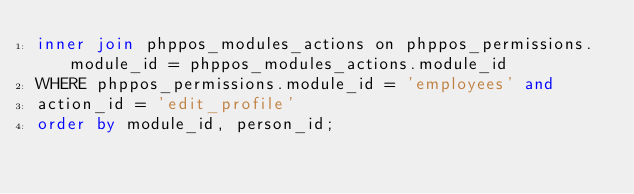Convert code to text. <code><loc_0><loc_0><loc_500><loc_500><_SQL_>inner join phppos_modules_actions on phppos_permissions.module_id = phppos_modules_actions.module_id
WHERE phppos_permissions.module_id = 'employees' and
action_id = 'edit_profile'
order by module_id, person_id;</code> 